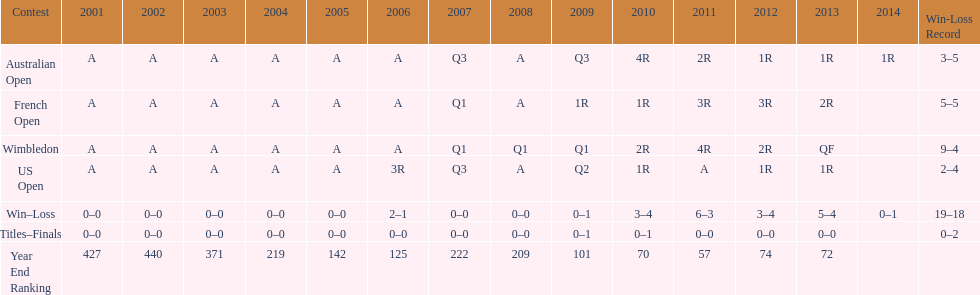What was this players ranking after 2005? 125. 